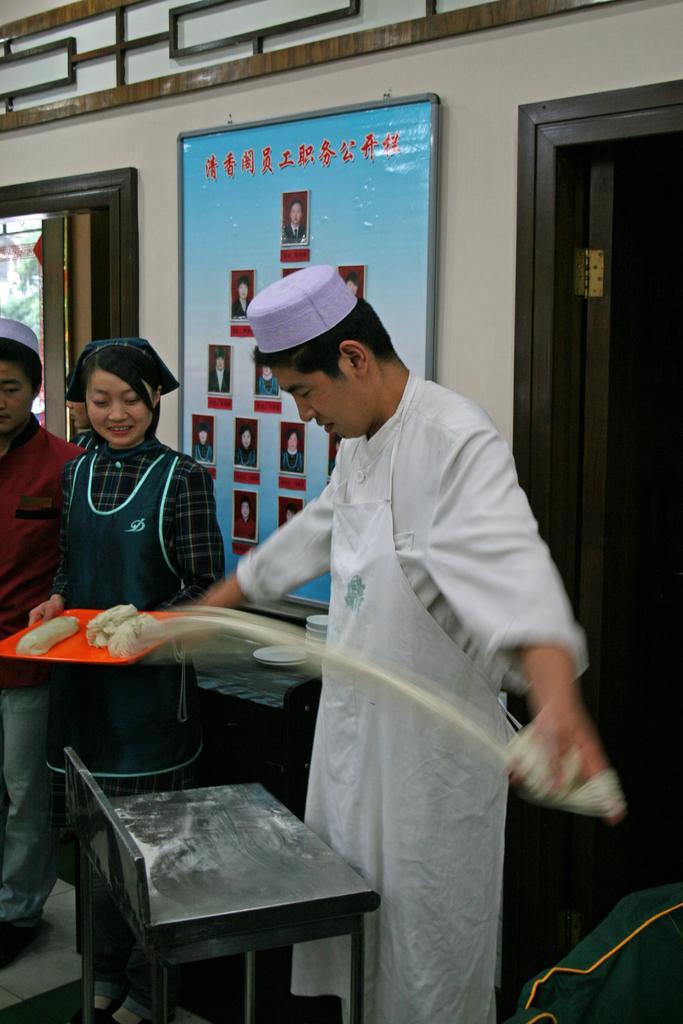How would you summarize this image in a sentence or two? In this image there is a chef holding a dough in his hand, in front of the person there is a stool, beside the person there is a woman standing and holding a tray with some doughs in it, beside the woman there is another woman standing, behind them there is a photo frame on the wall and there is an opened door and a glass window. 